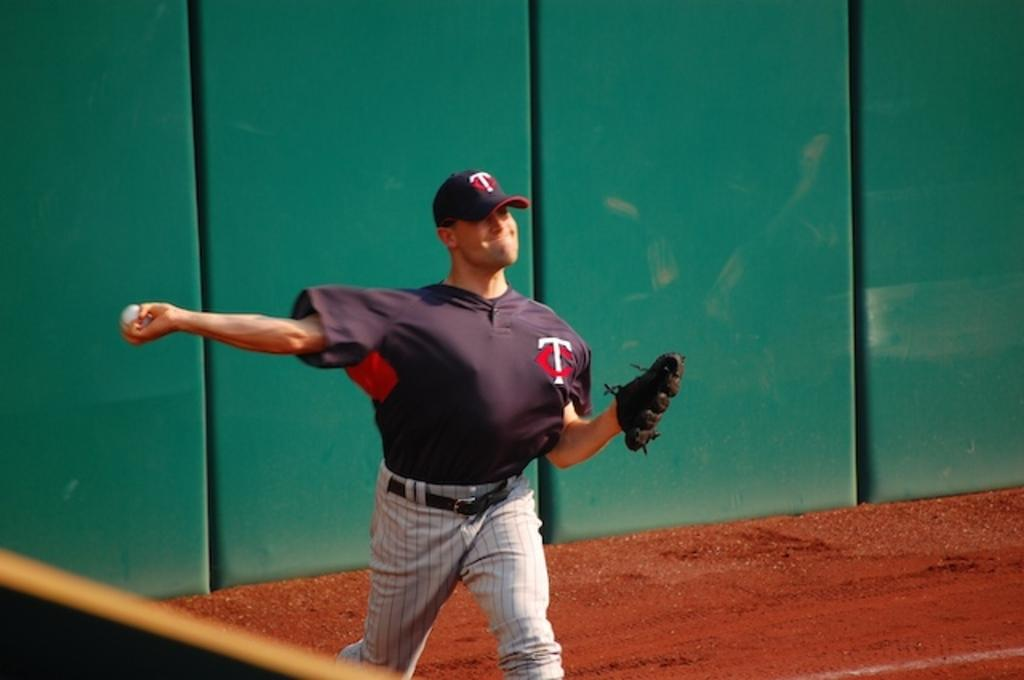<image>
Render a clear and concise summary of the photo. a baseball player with the letters t and c on his cap and jersey 